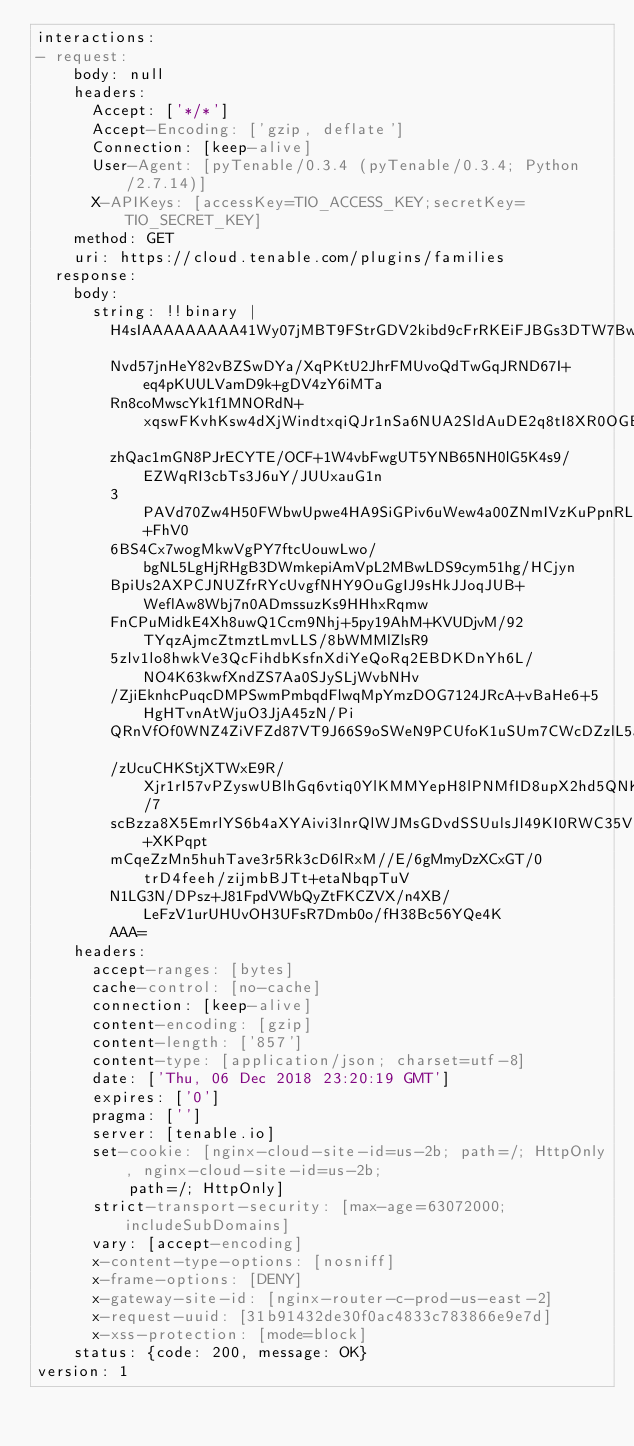<code> <loc_0><loc_0><loc_500><loc_500><_YAML_>interactions:
- request:
    body: null
    headers:
      Accept: ['*/*']
      Accept-Encoding: ['gzip, deflate']
      Connection: [keep-alive]
      User-Agent: [pyTenable/0.3.4 (pyTenable/0.3.4; Python/2.7.14)]
      X-APIKeys: [accessKey=TIO_ACCESS_KEY;secretKey=TIO_SECRET_KEY]
    method: GET
    uri: https://cloud.tenable.com/plugins/families
  response:
    body:
      string: !!binary |
        H4sIAAAAAAAAA41Wy07jMBT9FStrGDV2kibd9cFrRKEiFJBGs3DTW7BwYuQ6wID493Ghia81kplV
        Nvd57jnHeY82vBZSwDYa/XqPKtU2JhrFMUvoQdTwGqJRND67I+eq4pKUULVamD9k+gDV4zY6iMTa
        Rn8coMwscYk1f1MNORdN+xqswFKvhKsw4dXjWindtxqiQJr1nSa6NUA2SldAuDE2q8tI8XR0OGB9
        zhQac1mGN8PJrECYTE/OCF+1W4vbFwgUT5YNB65NH0lG5K4s9/EZWqRI3cbTs3J6uY/JUUxauG1n
        3PAVd70Zw4H50FWbwUpwe4HA9SiGPiv6uWew4a00ZNmIVzKuPpnRLZt49xrgpEZYnqiNpYp+FhV0
        6BS4Cx7wogMkwVgPY7ftcUouwLwo/bgNL5LgHjRHgB3DWmkepiAmVpL2MBwLDS9cym51hg/HCjyn
        BpiUs2AXPCJNUZfrRYcUvgfNHY9OuGgIJ9sHkJJoqJUB+WeflAw8Wbj7n0ADmssuzKs9HHhxRqmw
        FnCPuMidkE4Xh8uwQ1Ccm9Nhj+5py19AhM+KVUDjvM/92TYqzAjmcZtmztLmvLLS/8bWMMlZlsR9
        5zlv1lo8hwkVe3QcFihdbKsfnXdiYeQoRq2EBDKDnYh6L/NO4K63kwfXndZS7Aa0SJySLjWvbNHv
        /ZjiEknhcPuqcDMPSwmPmbqdFlwqMpYmzDOG7124JRcA+vBaHe6+5HgHTvnAtWjuO3JjA45zN/Pi
        QRnVfOf0WNZ4ZiVFZd87VT9J66S9oSWeN9PCUfoK1uSUm7CWcDZzlL5aTLttPJuJndjK6Xg23gcx
        /zUcuCHKStjXTWxE9R/Xjr1rI57vPZyswUBlhGq6vtiq0YlKMMYepH8lPNMfID8upX2hd5QNK9/7
        scBzza8X5EmrlYS6b4aXYAivi3lnrQlWJMsGDvdSSUulsJl49KI0RWC35VFwEWwkCUtc3+XKPqpt
        mCqeZzMn5huhTave3r5Rk3cD6lRxM//E/6gMmyDzXCxGT/0trD4feeh/zijmbBJTt+etaNbqpTuV
        N1LG3N/DPsz+J81FpdVWbQyZtFKCZVX/n4XB/LeFzV1urUHUvOH3UFsR7Dmb0o/fH38Bc56YQe4K
        AAA=
    headers:
      accept-ranges: [bytes]
      cache-control: [no-cache]
      connection: [keep-alive]
      content-encoding: [gzip]
      content-length: ['857']
      content-type: [application/json; charset=utf-8]
      date: ['Thu, 06 Dec 2018 23:20:19 GMT']
      expires: ['0']
      pragma: ['']
      server: [tenable.io]
      set-cookie: [nginx-cloud-site-id=us-2b; path=/; HttpOnly, nginx-cloud-site-id=us-2b;
          path=/; HttpOnly]
      strict-transport-security: [max-age=63072000; includeSubDomains]
      vary: [accept-encoding]
      x-content-type-options: [nosniff]
      x-frame-options: [DENY]
      x-gateway-site-id: [nginx-router-c-prod-us-east-2]
      x-request-uuid: [31b91432de30f0ac4833c783866e9e7d]
      x-xss-protection: [mode=block]
    status: {code: 200, message: OK}
version: 1
</code> 